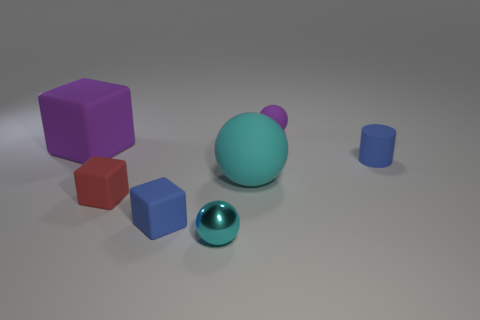What shape is the big purple object that is made of the same material as the blue cylinder?
Keep it short and to the point. Cube. Is the cyan shiny object the same size as the cyan matte sphere?
Your response must be concise. No. Is the material of the cyan object in front of the large cyan sphere the same as the large cyan sphere?
Offer a very short reply. No. Are there any other things that are made of the same material as the small cyan thing?
Your answer should be compact. No. There is a red rubber thing on the left side of the big object in front of the purple matte cube; how many small red cubes are to the right of it?
Keep it short and to the point. 0. There is a purple matte object to the right of the big rubber sphere; is it the same shape as the small red rubber object?
Ensure brevity in your answer.  No. What number of objects are tiny gray rubber cylinders or tiny objects in front of the small red matte cube?
Keep it short and to the point. 2. Is the number of small spheres on the right side of the large cyan thing greater than the number of tiny gray metallic things?
Keep it short and to the point. Yes. Are there the same number of red things that are right of the big cyan rubber ball and blue rubber objects behind the tiny red object?
Your response must be concise. No. There is a big object that is in front of the big purple rubber cube; are there any things in front of it?
Ensure brevity in your answer.  Yes. 